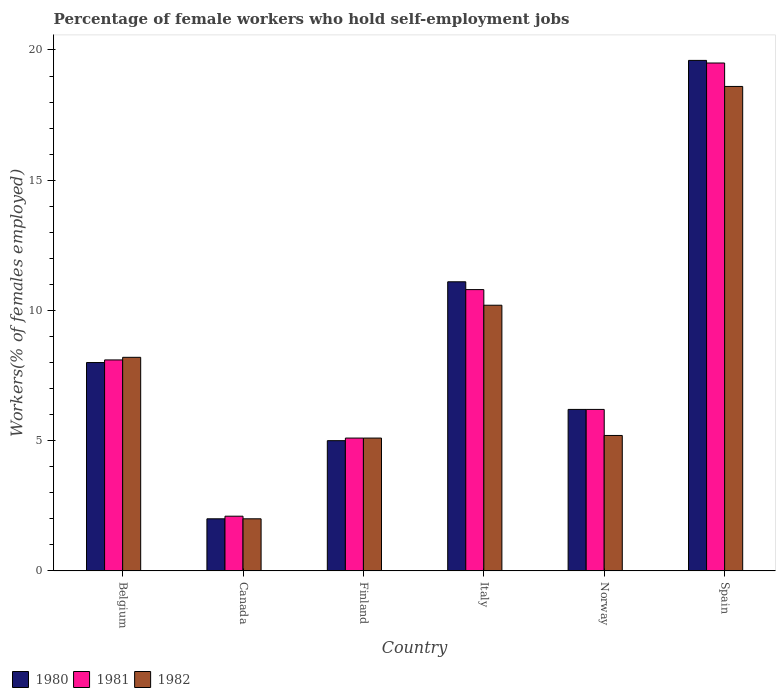How many groups of bars are there?
Offer a terse response. 6. How many bars are there on the 4th tick from the left?
Give a very brief answer. 3. What is the label of the 2nd group of bars from the left?
Ensure brevity in your answer.  Canada. In how many cases, is the number of bars for a given country not equal to the number of legend labels?
Offer a terse response. 0. What is the percentage of self-employed female workers in 1980 in Spain?
Offer a terse response. 19.6. Across all countries, what is the maximum percentage of self-employed female workers in 1981?
Give a very brief answer. 19.5. What is the total percentage of self-employed female workers in 1980 in the graph?
Give a very brief answer. 51.9. What is the difference between the percentage of self-employed female workers in 1980 in Norway and that in Spain?
Offer a terse response. -13.4. What is the difference between the percentage of self-employed female workers in 1980 in Norway and the percentage of self-employed female workers in 1981 in Finland?
Your answer should be very brief. 1.1. What is the average percentage of self-employed female workers in 1981 per country?
Provide a succinct answer. 8.63. What is the difference between the percentage of self-employed female workers of/in 1980 and percentage of self-employed female workers of/in 1981 in Italy?
Provide a short and direct response. 0.3. In how many countries, is the percentage of self-employed female workers in 1982 greater than 16 %?
Your answer should be compact. 1. What is the ratio of the percentage of self-employed female workers in 1981 in Finland to that in Italy?
Provide a short and direct response. 0.47. What is the difference between the highest and the second highest percentage of self-employed female workers in 1981?
Keep it short and to the point. -2.7. What is the difference between the highest and the lowest percentage of self-employed female workers in 1982?
Give a very brief answer. 16.6. In how many countries, is the percentage of self-employed female workers in 1980 greater than the average percentage of self-employed female workers in 1980 taken over all countries?
Your answer should be compact. 2. What does the 1st bar from the right in Spain represents?
Offer a terse response. 1982. How many bars are there?
Keep it short and to the point. 18. Are all the bars in the graph horizontal?
Offer a terse response. No. How many countries are there in the graph?
Offer a terse response. 6. Where does the legend appear in the graph?
Provide a succinct answer. Bottom left. How many legend labels are there?
Keep it short and to the point. 3. How are the legend labels stacked?
Your answer should be very brief. Horizontal. What is the title of the graph?
Make the answer very short. Percentage of female workers who hold self-employment jobs. Does "2011" appear as one of the legend labels in the graph?
Make the answer very short. No. What is the label or title of the X-axis?
Give a very brief answer. Country. What is the label or title of the Y-axis?
Offer a terse response. Workers(% of females employed). What is the Workers(% of females employed) in 1981 in Belgium?
Keep it short and to the point. 8.1. What is the Workers(% of females employed) of 1982 in Belgium?
Provide a succinct answer. 8.2. What is the Workers(% of females employed) of 1980 in Canada?
Provide a short and direct response. 2. What is the Workers(% of females employed) in 1981 in Canada?
Your answer should be compact. 2.1. What is the Workers(% of females employed) in 1980 in Finland?
Provide a succinct answer. 5. What is the Workers(% of females employed) of 1981 in Finland?
Your response must be concise. 5.1. What is the Workers(% of females employed) in 1982 in Finland?
Provide a succinct answer. 5.1. What is the Workers(% of females employed) in 1980 in Italy?
Provide a short and direct response. 11.1. What is the Workers(% of females employed) in 1981 in Italy?
Make the answer very short. 10.8. What is the Workers(% of females employed) in 1982 in Italy?
Your response must be concise. 10.2. What is the Workers(% of females employed) of 1980 in Norway?
Offer a very short reply. 6.2. What is the Workers(% of females employed) in 1981 in Norway?
Offer a terse response. 6.2. What is the Workers(% of females employed) in 1982 in Norway?
Your response must be concise. 5.2. What is the Workers(% of females employed) of 1980 in Spain?
Offer a very short reply. 19.6. What is the Workers(% of females employed) of 1981 in Spain?
Offer a very short reply. 19.5. What is the Workers(% of females employed) in 1982 in Spain?
Provide a short and direct response. 18.6. Across all countries, what is the maximum Workers(% of females employed) in 1980?
Your answer should be very brief. 19.6. Across all countries, what is the maximum Workers(% of females employed) of 1981?
Provide a short and direct response. 19.5. Across all countries, what is the maximum Workers(% of females employed) of 1982?
Give a very brief answer. 18.6. Across all countries, what is the minimum Workers(% of females employed) of 1980?
Your response must be concise. 2. Across all countries, what is the minimum Workers(% of females employed) in 1981?
Offer a very short reply. 2.1. What is the total Workers(% of females employed) in 1980 in the graph?
Provide a short and direct response. 51.9. What is the total Workers(% of females employed) of 1981 in the graph?
Ensure brevity in your answer.  51.8. What is the total Workers(% of females employed) in 1982 in the graph?
Your answer should be compact. 49.3. What is the difference between the Workers(% of females employed) in 1980 in Belgium and that in Canada?
Your answer should be compact. 6. What is the difference between the Workers(% of females employed) of 1981 in Belgium and that in Canada?
Provide a succinct answer. 6. What is the difference between the Workers(% of females employed) of 1982 in Belgium and that in Canada?
Provide a succinct answer. 6.2. What is the difference between the Workers(% of females employed) of 1982 in Belgium and that in Finland?
Give a very brief answer. 3.1. What is the difference between the Workers(% of females employed) of 1980 in Belgium and that in Italy?
Give a very brief answer. -3.1. What is the difference between the Workers(% of females employed) in 1982 in Belgium and that in Italy?
Provide a short and direct response. -2. What is the difference between the Workers(% of females employed) of 1980 in Belgium and that in Norway?
Ensure brevity in your answer.  1.8. What is the difference between the Workers(% of females employed) of 1980 in Belgium and that in Spain?
Offer a terse response. -11.6. What is the difference between the Workers(% of females employed) in 1981 in Belgium and that in Spain?
Your answer should be compact. -11.4. What is the difference between the Workers(% of females employed) of 1982 in Belgium and that in Spain?
Provide a succinct answer. -10.4. What is the difference between the Workers(% of females employed) of 1980 in Canada and that in Italy?
Ensure brevity in your answer.  -9.1. What is the difference between the Workers(% of females employed) of 1982 in Canada and that in Italy?
Provide a short and direct response. -8.2. What is the difference between the Workers(% of females employed) of 1980 in Canada and that in Norway?
Provide a succinct answer. -4.2. What is the difference between the Workers(% of females employed) in 1982 in Canada and that in Norway?
Offer a terse response. -3.2. What is the difference between the Workers(% of females employed) of 1980 in Canada and that in Spain?
Provide a short and direct response. -17.6. What is the difference between the Workers(% of females employed) in 1981 in Canada and that in Spain?
Your answer should be very brief. -17.4. What is the difference between the Workers(% of females employed) in 1982 in Canada and that in Spain?
Offer a very short reply. -16.6. What is the difference between the Workers(% of females employed) of 1980 in Finland and that in Italy?
Provide a succinct answer. -6.1. What is the difference between the Workers(% of females employed) of 1982 in Finland and that in Italy?
Your answer should be very brief. -5.1. What is the difference between the Workers(% of females employed) of 1980 in Finland and that in Norway?
Make the answer very short. -1.2. What is the difference between the Workers(% of females employed) in 1981 in Finland and that in Norway?
Provide a succinct answer. -1.1. What is the difference between the Workers(% of females employed) of 1982 in Finland and that in Norway?
Ensure brevity in your answer.  -0.1. What is the difference between the Workers(% of females employed) in 1980 in Finland and that in Spain?
Offer a terse response. -14.6. What is the difference between the Workers(% of females employed) in 1981 in Finland and that in Spain?
Make the answer very short. -14.4. What is the difference between the Workers(% of females employed) of 1982 in Finland and that in Spain?
Your answer should be very brief. -13.5. What is the difference between the Workers(% of females employed) of 1980 in Italy and that in Norway?
Offer a terse response. 4.9. What is the difference between the Workers(% of females employed) of 1981 in Italy and that in Norway?
Offer a very short reply. 4.6. What is the difference between the Workers(% of females employed) in 1982 in Italy and that in Norway?
Ensure brevity in your answer.  5. What is the difference between the Workers(% of females employed) of 1980 in Italy and that in Spain?
Provide a short and direct response. -8.5. What is the difference between the Workers(% of females employed) in 1981 in Italy and that in Spain?
Make the answer very short. -8.7. What is the difference between the Workers(% of females employed) of 1982 in Italy and that in Spain?
Your answer should be very brief. -8.4. What is the difference between the Workers(% of females employed) of 1980 in Norway and that in Spain?
Your response must be concise. -13.4. What is the difference between the Workers(% of females employed) of 1981 in Norway and that in Spain?
Give a very brief answer. -13.3. What is the difference between the Workers(% of females employed) of 1980 in Belgium and the Workers(% of females employed) of 1981 in Canada?
Offer a very short reply. 5.9. What is the difference between the Workers(% of females employed) in 1980 in Belgium and the Workers(% of females employed) in 1982 in Canada?
Your response must be concise. 6. What is the difference between the Workers(% of females employed) in 1981 in Belgium and the Workers(% of females employed) in 1982 in Canada?
Your answer should be compact. 6.1. What is the difference between the Workers(% of females employed) in 1980 in Belgium and the Workers(% of females employed) in 1982 in Finland?
Offer a very short reply. 2.9. What is the difference between the Workers(% of females employed) in 1981 in Belgium and the Workers(% of females employed) in 1982 in Finland?
Offer a terse response. 3. What is the difference between the Workers(% of females employed) in 1980 in Belgium and the Workers(% of females employed) in 1982 in Norway?
Provide a succinct answer. 2.8. What is the difference between the Workers(% of females employed) of 1981 in Belgium and the Workers(% of females employed) of 1982 in Norway?
Provide a short and direct response. 2.9. What is the difference between the Workers(% of females employed) of 1980 in Belgium and the Workers(% of females employed) of 1982 in Spain?
Provide a short and direct response. -10.6. What is the difference between the Workers(% of females employed) of 1980 in Canada and the Workers(% of females employed) of 1982 in Finland?
Offer a very short reply. -3.1. What is the difference between the Workers(% of females employed) of 1980 in Canada and the Workers(% of females employed) of 1981 in Norway?
Make the answer very short. -4.2. What is the difference between the Workers(% of females employed) in 1980 in Canada and the Workers(% of females employed) in 1982 in Norway?
Keep it short and to the point. -3.2. What is the difference between the Workers(% of females employed) of 1981 in Canada and the Workers(% of females employed) of 1982 in Norway?
Provide a short and direct response. -3.1. What is the difference between the Workers(% of females employed) of 1980 in Canada and the Workers(% of females employed) of 1981 in Spain?
Keep it short and to the point. -17.5. What is the difference between the Workers(% of females employed) in 1980 in Canada and the Workers(% of females employed) in 1982 in Spain?
Give a very brief answer. -16.6. What is the difference between the Workers(% of females employed) in 1981 in Canada and the Workers(% of females employed) in 1982 in Spain?
Your answer should be compact. -16.5. What is the difference between the Workers(% of females employed) in 1980 in Finland and the Workers(% of females employed) in 1982 in Italy?
Your answer should be compact. -5.2. What is the difference between the Workers(% of females employed) of 1980 in Finland and the Workers(% of females employed) of 1981 in Norway?
Provide a succinct answer. -1.2. What is the difference between the Workers(% of females employed) in 1980 in Finland and the Workers(% of females employed) in 1982 in Spain?
Offer a very short reply. -13.6. What is the difference between the Workers(% of females employed) of 1980 in Italy and the Workers(% of females employed) of 1981 in Norway?
Provide a succinct answer. 4.9. What is the difference between the Workers(% of females employed) in 1981 in Italy and the Workers(% of females employed) in 1982 in Norway?
Provide a short and direct response. 5.6. What is the difference between the Workers(% of females employed) in 1981 in Italy and the Workers(% of females employed) in 1982 in Spain?
Your response must be concise. -7.8. What is the difference between the Workers(% of females employed) of 1981 in Norway and the Workers(% of females employed) of 1982 in Spain?
Offer a very short reply. -12.4. What is the average Workers(% of females employed) in 1980 per country?
Ensure brevity in your answer.  8.65. What is the average Workers(% of females employed) in 1981 per country?
Provide a succinct answer. 8.63. What is the average Workers(% of females employed) in 1982 per country?
Your response must be concise. 8.22. What is the difference between the Workers(% of females employed) of 1980 and Workers(% of females employed) of 1982 in Belgium?
Give a very brief answer. -0.2. What is the difference between the Workers(% of females employed) of 1980 and Workers(% of females employed) of 1982 in Canada?
Provide a succinct answer. 0. What is the difference between the Workers(% of females employed) in 1981 and Workers(% of females employed) in 1982 in Canada?
Ensure brevity in your answer.  0.1. What is the difference between the Workers(% of females employed) in 1980 and Workers(% of females employed) in 1981 in Finland?
Make the answer very short. -0.1. What is the difference between the Workers(% of females employed) in 1981 and Workers(% of females employed) in 1982 in Finland?
Provide a short and direct response. 0. What is the difference between the Workers(% of females employed) of 1980 and Workers(% of females employed) of 1981 in Italy?
Your response must be concise. 0.3. What is the difference between the Workers(% of females employed) of 1980 and Workers(% of females employed) of 1981 in Norway?
Offer a very short reply. 0. What is the difference between the Workers(% of females employed) of 1981 and Workers(% of females employed) of 1982 in Norway?
Your response must be concise. 1. What is the difference between the Workers(% of females employed) in 1980 and Workers(% of females employed) in 1982 in Spain?
Your response must be concise. 1. What is the difference between the Workers(% of females employed) of 1981 and Workers(% of females employed) of 1982 in Spain?
Provide a short and direct response. 0.9. What is the ratio of the Workers(% of females employed) in 1981 in Belgium to that in Canada?
Your response must be concise. 3.86. What is the ratio of the Workers(% of females employed) in 1982 in Belgium to that in Canada?
Make the answer very short. 4.1. What is the ratio of the Workers(% of females employed) of 1981 in Belgium to that in Finland?
Provide a succinct answer. 1.59. What is the ratio of the Workers(% of females employed) in 1982 in Belgium to that in Finland?
Offer a terse response. 1.61. What is the ratio of the Workers(% of females employed) of 1980 in Belgium to that in Italy?
Offer a very short reply. 0.72. What is the ratio of the Workers(% of females employed) of 1982 in Belgium to that in Italy?
Ensure brevity in your answer.  0.8. What is the ratio of the Workers(% of females employed) of 1980 in Belgium to that in Norway?
Keep it short and to the point. 1.29. What is the ratio of the Workers(% of females employed) in 1981 in Belgium to that in Norway?
Your answer should be compact. 1.31. What is the ratio of the Workers(% of females employed) in 1982 in Belgium to that in Norway?
Provide a short and direct response. 1.58. What is the ratio of the Workers(% of females employed) in 1980 in Belgium to that in Spain?
Your response must be concise. 0.41. What is the ratio of the Workers(% of females employed) in 1981 in Belgium to that in Spain?
Your answer should be very brief. 0.42. What is the ratio of the Workers(% of females employed) of 1982 in Belgium to that in Spain?
Keep it short and to the point. 0.44. What is the ratio of the Workers(% of females employed) of 1981 in Canada to that in Finland?
Provide a short and direct response. 0.41. What is the ratio of the Workers(% of females employed) in 1982 in Canada to that in Finland?
Provide a succinct answer. 0.39. What is the ratio of the Workers(% of females employed) of 1980 in Canada to that in Italy?
Your response must be concise. 0.18. What is the ratio of the Workers(% of females employed) of 1981 in Canada to that in Italy?
Your answer should be compact. 0.19. What is the ratio of the Workers(% of females employed) in 1982 in Canada to that in Italy?
Provide a short and direct response. 0.2. What is the ratio of the Workers(% of females employed) of 1980 in Canada to that in Norway?
Your response must be concise. 0.32. What is the ratio of the Workers(% of females employed) in 1981 in Canada to that in Norway?
Give a very brief answer. 0.34. What is the ratio of the Workers(% of females employed) of 1982 in Canada to that in Norway?
Offer a very short reply. 0.38. What is the ratio of the Workers(% of females employed) of 1980 in Canada to that in Spain?
Make the answer very short. 0.1. What is the ratio of the Workers(% of females employed) of 1981 in Canada to that in Spain?
Offer a very short reply. 0.11. What is the ratio of the Workers(% of females employed) in 1982 in Canada to that in Spain?
Keep it short and to the point. 0.11. What is the ratio of the Workers(% of females employed) of 1980 in Finland to that in Italy?
Provide a succinct answer. 0.45. What is the ratio of the Workers(% of females employed) of 1981 in Finland to that in Italy?
Offer a very short reply. 0.47. What is the ratio of the Workers(% of females employed) in 1982 in Finland to that in Italy?
Ensure brevity in your answer.  0.5. What is the ratio of the Workers(% of females employed) in 1980 in Finland to that in Norway?
Your answer should be very brief. 0.81. What is the ratio of the Workers(% of females employed) in 1981 in Finland to that in Norway?
Provide a succinct answer. 0.82. What is the ratio of the Workers(% of females employed) of 1982 in Finland to that in Norway?
Ensure brevity in your answer.  0.98. What is the ratio of the Workers(% of females employed) of 1980 in Finland to that in Spain?
Offer a terse response. 0.26. What is the ratio of the Workers(% of females employed) of 1981 in Finland to that in Spain?
Your response must be concise. 0.26. What is the ratio of the Workers(% of females employed) of 1982 in Finland to that in Spain?
Your answer should be compact. 0.27. What is the ratio of the Workers(% of females employed) of 1980 in Italy to that in Norway?
Your response must be concise. 1.79. What is the ratio of the Workers(% of females employed) of 1981 in Italy to that in Norway?
Your answer should be very brief. 1.74. What is the ratio of the Workers(% of females employed) of 1982 in Italy to that in Norway?
Offer a terse response. 1.96. What is the ratio of the Workers(% of females employed) of 1980 in Italy to that in Spain?
Provide a short and direct response. 0.57. What is the ratio of the Workers(% of females employed) of 1981 in Italy to that in Spain?
Make the answer very short. 0.55. What is the ratio of the Workers(% of females employed) in 1982 in Italy to that in Spain?
Your answer should be very brief. 0.55. What is the ratio of the Workers(% of females employed) in 1980 in Norway to that in Spain?
Give a very brief answer. 0.32. What is the ratio of the Workers(% of females employed) in 1981 in Norway to that in Spain?
Offer a terse response. 0.32. What is the ratio of the Workers(% of females employed) in 1982 in Norway to that in Spain?
Offer a very short reply. 0.28. What is the difference between the highest and the second highest Workers(% of females employed) of 1980?
Ensure brevity in your answer.  8.5. What is the difference between the highest and the second highest Workers(% of females employed) in 1981?
Offer a terse response. 8.7. What is the difference between the highest and the second highest Workers(% of females employed) of 1982?
Your response must be concise. 8.4. What is the difference between the highest and the lowest Workers(% of females employed) of 1980?
Offer a terse response. 17.6. What is the difference between the highest and the lowest Workers(% of females employed) in 1982?
Keep it short and to the point. 16.6. 